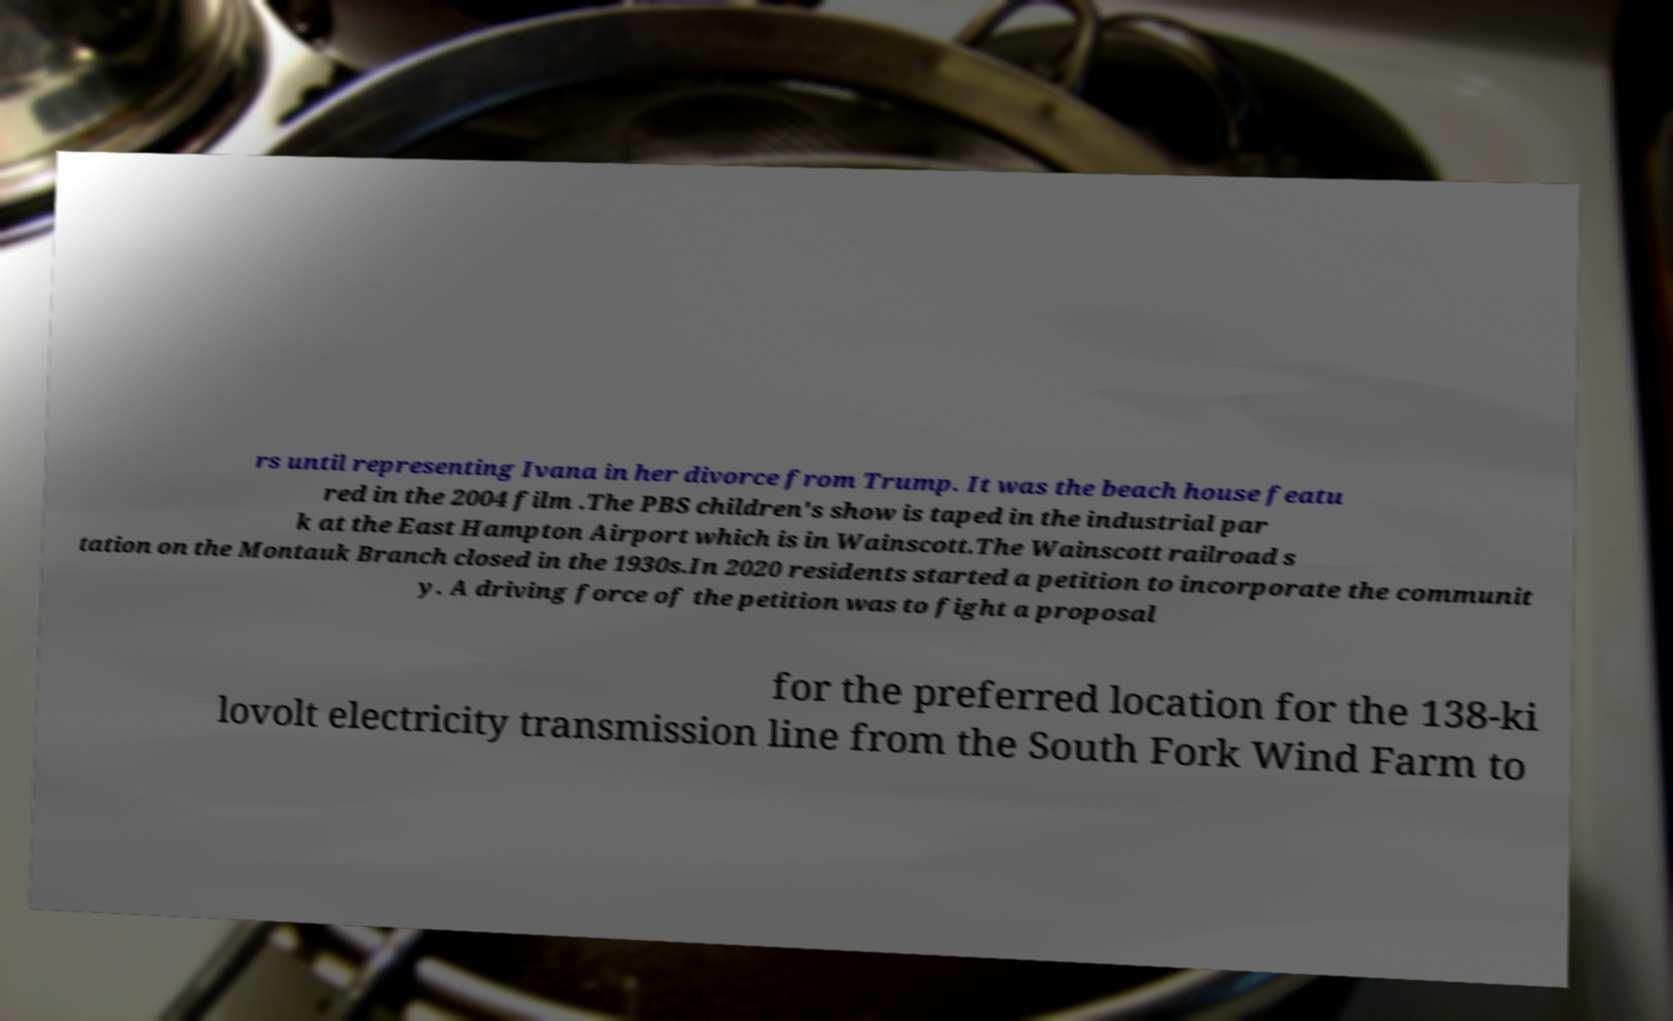Could you extract and type out the text from this image? rs until representing Ivana in her divorce from Trump. It was the beach house featu red in the 2004 film .The PBS children's show is taped in the industrial par k at the East Hampton Airport which is in Wainscott.The Wainscott railroad s tation on the Montauk Branch closed in the 1930s.In 2020 residents started a petition to incorporate the communit y. A driving force of the petition was to fight a proposal for the preferred location for the 138-ki lovolt electricity transmission line from the South Fork Wind Farm to 